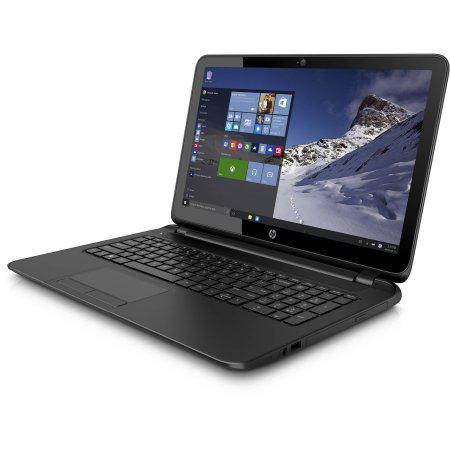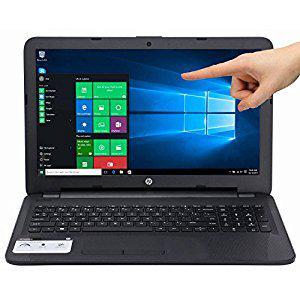The first image is the image on the left, the second image is the image on the right. Given the left and right images, does the statement "The laptop on the right is displayed head-on, opened at a right angle, with its screen showing blue and white circle logo." hold true? Answer yes or no. No. 